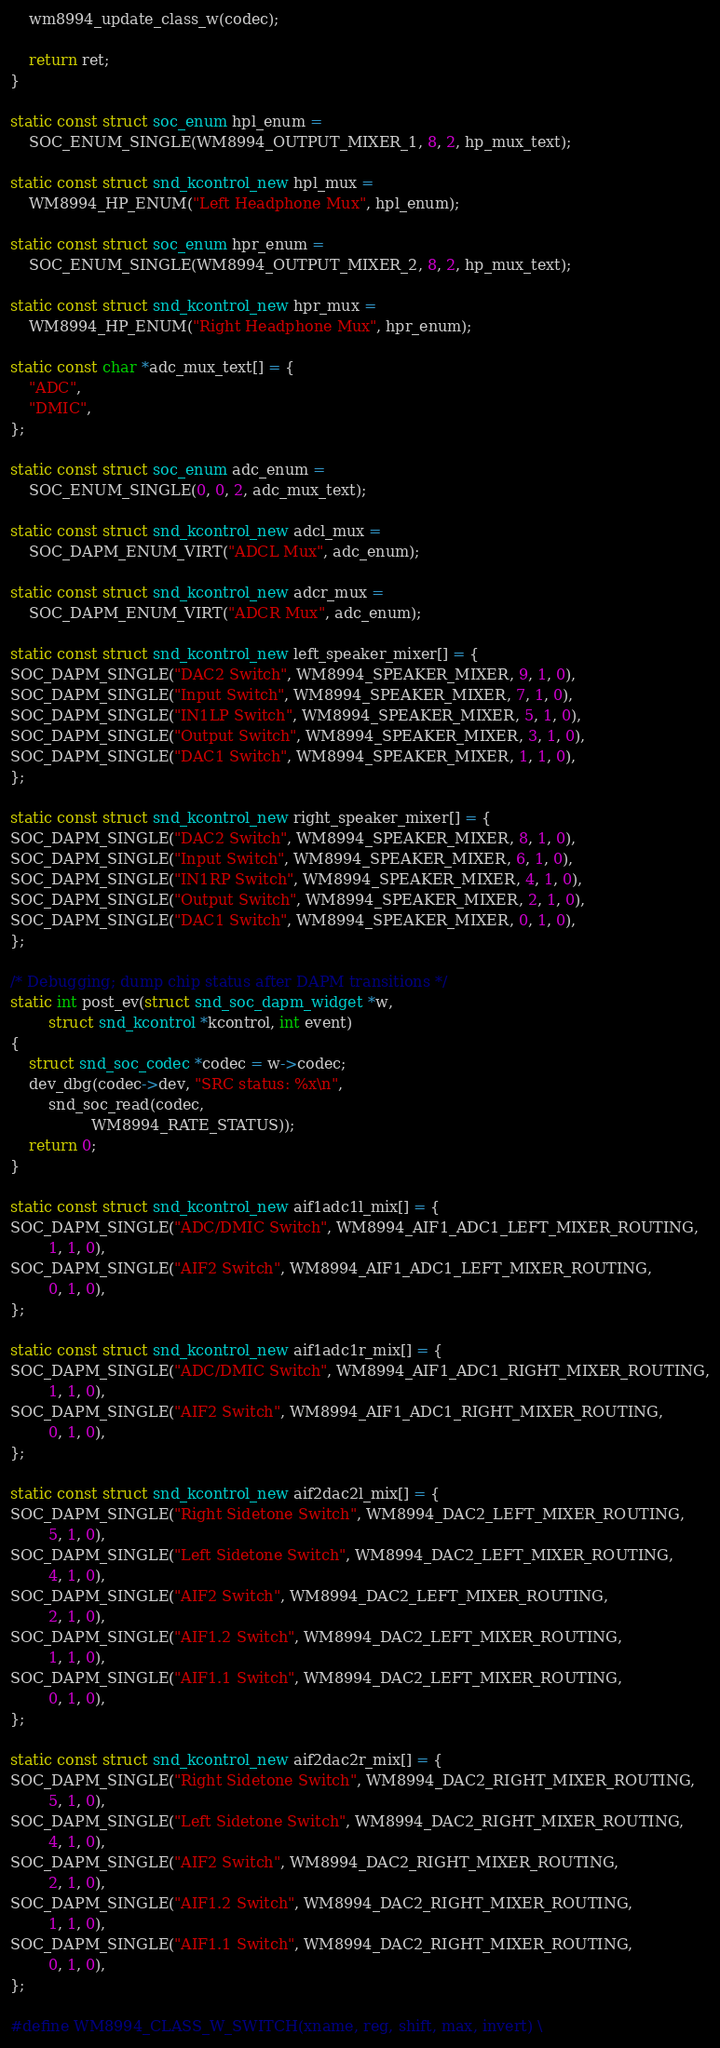Convert code to text. <code><loc_0><loc_0><loc_500><loc_500><_C_>
	wm8994_update_class_w(codec);

	return ret;
}

static const struct soc_enum hpl_enum =
	SOC_ENUM_SINGLE(WM8994_OUTPUT_MIXER_1, 8, 2, hp_mux_text);

static const struct snd_kcontrol_new hpl_mux =
	WM8994_HP_ENUM("Left Headphone Mux", hpl_enum);

static const struct soc_enum hpr_enum =
	SOC_ENUM_SINGLE(WM8994_OUTPUT_MIXER_2, 8, 2, hp_mux_text);

static const struct snd_kcontrol_new hpr_mux =
	WM8994_HP_ENUM("Right Headphone Mux", hpr_enum);

static const char *adc_mux_text[] = {
	"ADC",
	"DMIC",
};

static const struct soc_enum adc_enum =
	SOC_ENUM_SINGLE(0, 0, 2, adc_mux_text);

static const struct snd_kcontrol_new adcl_mux =
	SOC_DAPM_ENUM_VIRT("ADCL Mux", adc_enum);

static const struct snd_kcontrol_new adcr_mux =
	SOC_DAPM_ENUM_VIRT("ADCR Mux", adc_enum);

static const struct snd_kcontrol_new left_speaker_mixer[] = {
SOC_DAPM_SINGLE("DAC2 Switch", WM8994_SPEAKER_MIXER, 9, 1, 0),
SOC_DAPM_SINGLE("Input Switch", WM8994_SPEAKER_MIXER, 7, 1, 0),
SOC_DAPM_SINGLE("IN1LP Switch", WM8994_SPEAKER_MIXER, 5, 1, 0),
SOC_DAPM_SINGLE("Output Switch", WM8994_SPEAKER_MIXER, 3, 1, 0),
SOC_DAPM_SINGLE("DAC1 Switch", WM8994_SPEAKER_MIXER, 1, 1, 0),
};

static const struct snd_kcontrol_new right_speaker_mixer[] = {
SOC_DAPM_SINGLE("DAC2 Switch", WM8994_SPEAKER_MIXER, 8, 1, 0),
SOC_DAPM_SINGLE("Input Switch", WM8994_SPEAKER_MIXER, 6, 1, 0),
SOC_DAPM_SINGLE("IN1RP Switch", WM8994_SPEAKER_MIXER, 4, 1, 0),
SOC_DAPM_SINGLE("Output Switch", WM8994_SPEAKER_MIXER, 2, 1, 0),
SOC_DAPM_SINGLE("DAC1 Switch", WM8994_SPEAKER_MIXER, 0, 1, 0),
};

/* Debugging; dump chip status after DAPM transitions */
static int post_ev(struct snd_soc_dapm_widget *w,
	    struct snd_kcontrol *kcontrol, int event)
{
	struct snd_soc_codec *codec = w->codec;
	dev_dbg(codec->dev, "SRC status: %x\n",
		snd_soc_read(codec,
			     WM8994_RATE_STATUS));
	return 0;
}

static const struct snd_kcontrol_new aif1adc1l_mix[] = {
SOC_DAPM_SINGLE("ADC/DMIC Switch", WM8994_AIF1_ADC1_LEFT_MIXER_ROUTING,
		1, 1, 0),
SOC_DAPM_SINGLE("AIF2 Switch", WM8994_AIF1_ADC1_LEFT_MIXER_ROUTING,
		0, 1, 0),
};

static const struct snd_kcontrol_new aif1adc1r_mix[] = {
SOC_DAPM_SINGLE("ADC/DMIC Switch", WM8994_AIF1_ADC1_RIGHT_MIXER_ROUTING,
		1, 1, 0),
SOC_DAPM_SINGLE("AIF2 Switch", WM8994_AIF1_ADC1_RIGHT_MIXER_ROUTING,
		0, 1, 0),
};

static const struct snd_kcontrol_new aif2dac2l_mix[] = {
SOC_DAPM_SINGLE("Right Sidetone Switch", WM8994_DAC2_LEFT_MIXER_ROUTING,
		5, 1, 0),
SOC_DAPM_SINGLE("Left Sidetone Switch", WM8994_DAC2_LEFT_MIXER_ROUTING,
		4, 1, 0),
SOC_DAPM_SINGLE("AIF2 Switch", WM8994_DAC2_LEFT_MIXER_ROUTING,
		2, 1, 0),
SOC_DAPM_SINGLE("AIF1.2 Switch", WM8994_DAC2_LEFT_MIXER_ROUTING,
		1, 1, 0),
SOC_DAPM_SINGLE("AIF1.1 Switch", WM8994_DAC2_LEFT_MIXER_ROUTING,
		0, 1, 0),
};

static const struct snd_kcontrol_new aif2dac2r_mix[] = {
SOC_DAPM_SINGLE("Right Sidetone Switch", WM8994_DAC2_RIGHT_MIXER_ROUTING,
		5, 1, 0),
SOC_DAPM_SINGLE("Left Sidetone Switch", WM8994_DAC2_RIGHT_MIXER_ROUTING,
		4, 1, 0),
SOC_DAPM_SINGLE("AIF2 Switch", WM8994_DAC2_RIGHT_MIXER_ROUTING,
		2, 1, 0),
SOC_DAPM_SINGLE("AIF1.2 Switch", WM8994_DAC2_RIGHT_MIXER_ROUTING,
		1, 1, 0),
SOC_DAPM_SINGLE("AIF1.1 Switch", WM8994_DAC2_RIGHT_MIXER_ROUTING,
		0, 1, 0),
};

#define WM8994_CLASS_W_SWITCH(xname, reg, shift, max, invert) \</code> 